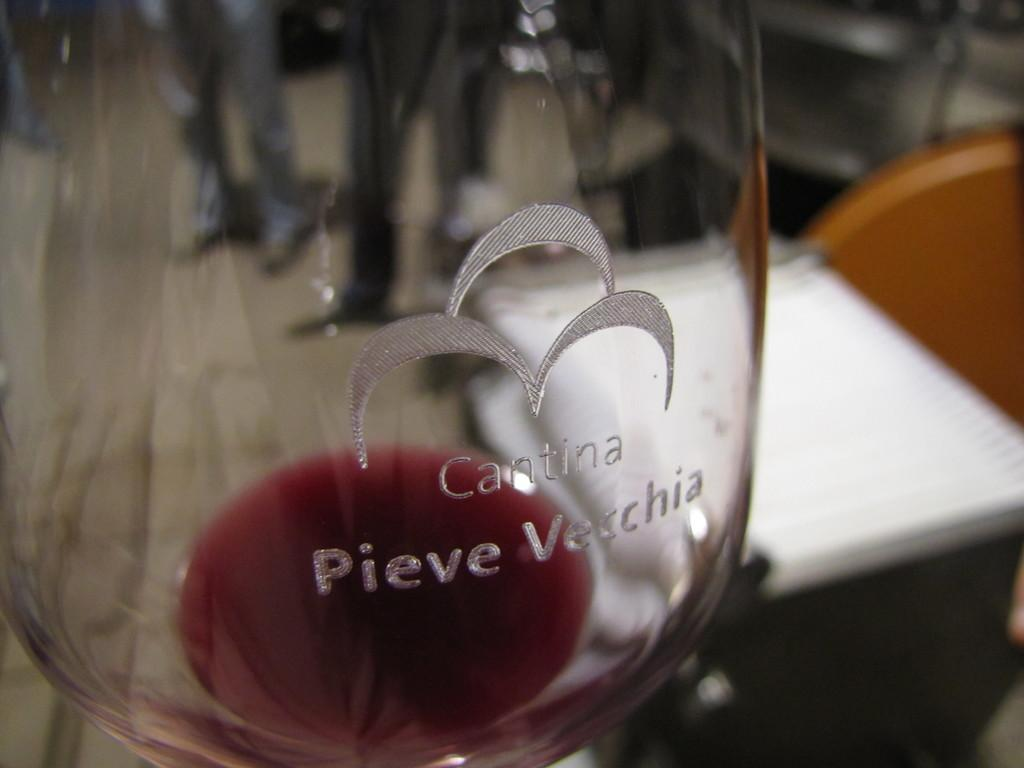<image>
Provide a brief description of the given image. A glass made of Cantina Pieve Vecchia sits on a table 